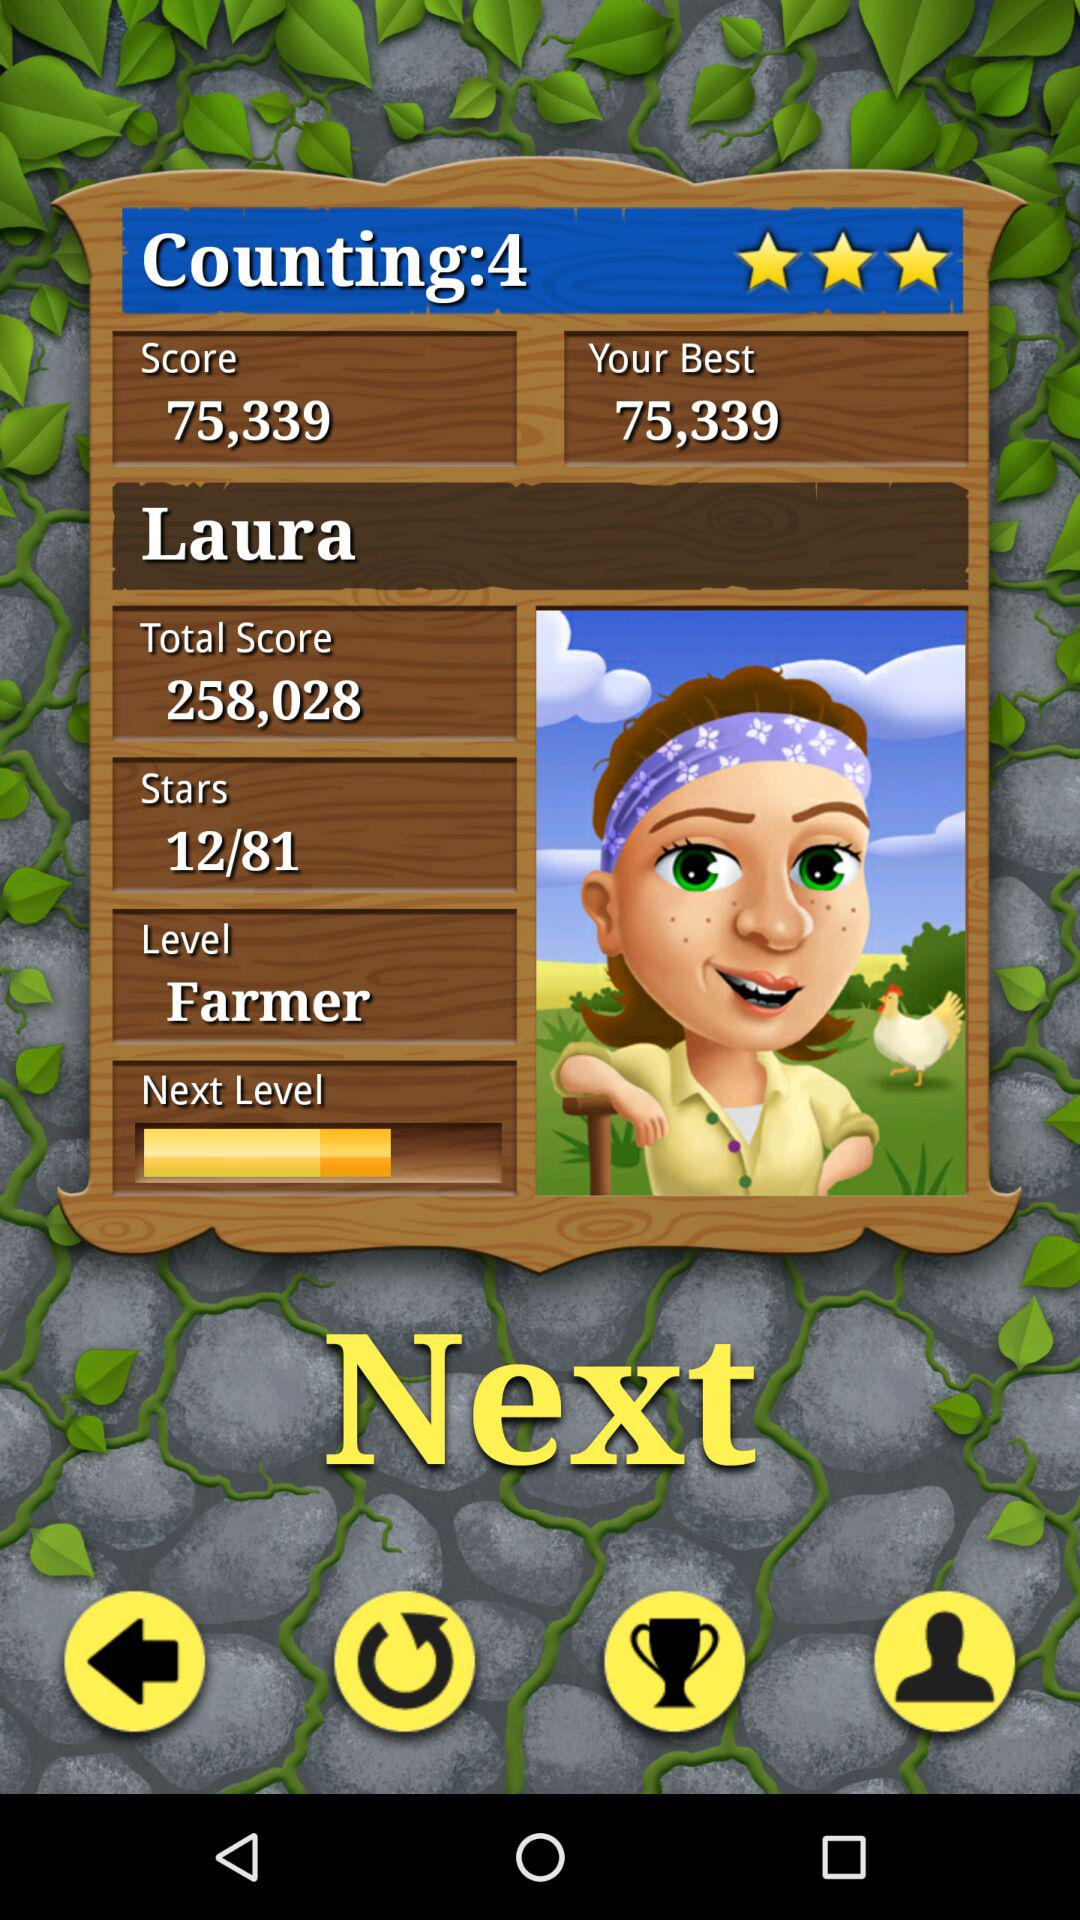How many stars does the person currently have? The person currently has 12 stars. 